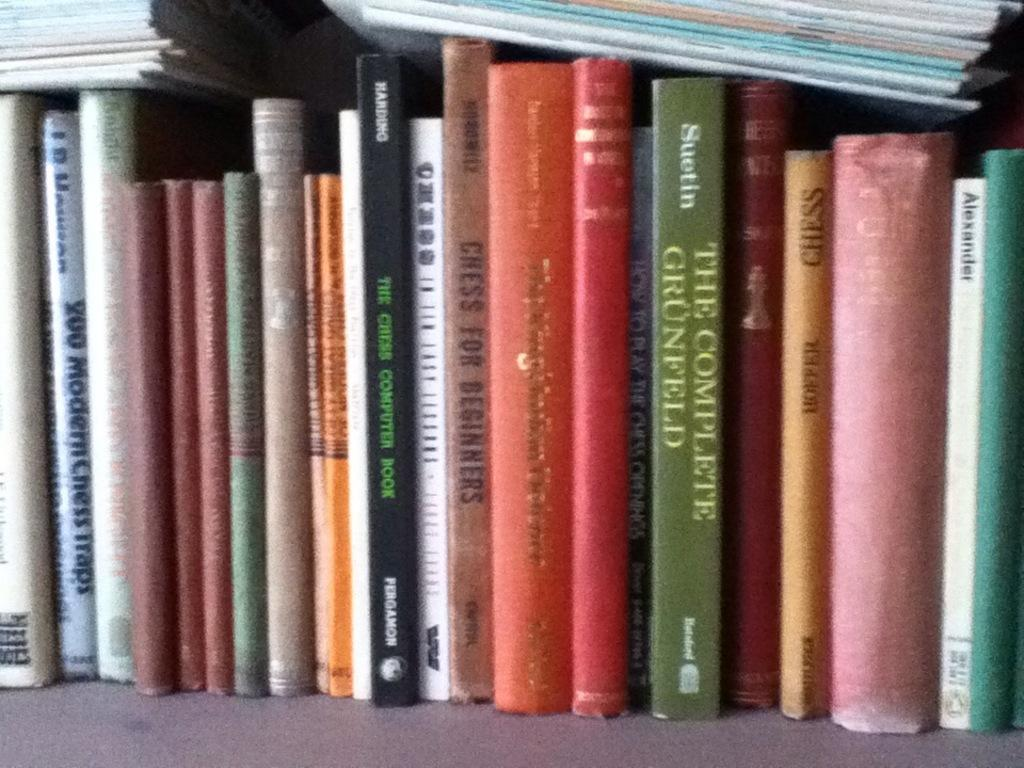<image>
Share a concise interpretation of the image provided. The bookshelf consists of about 20 different types of books. 